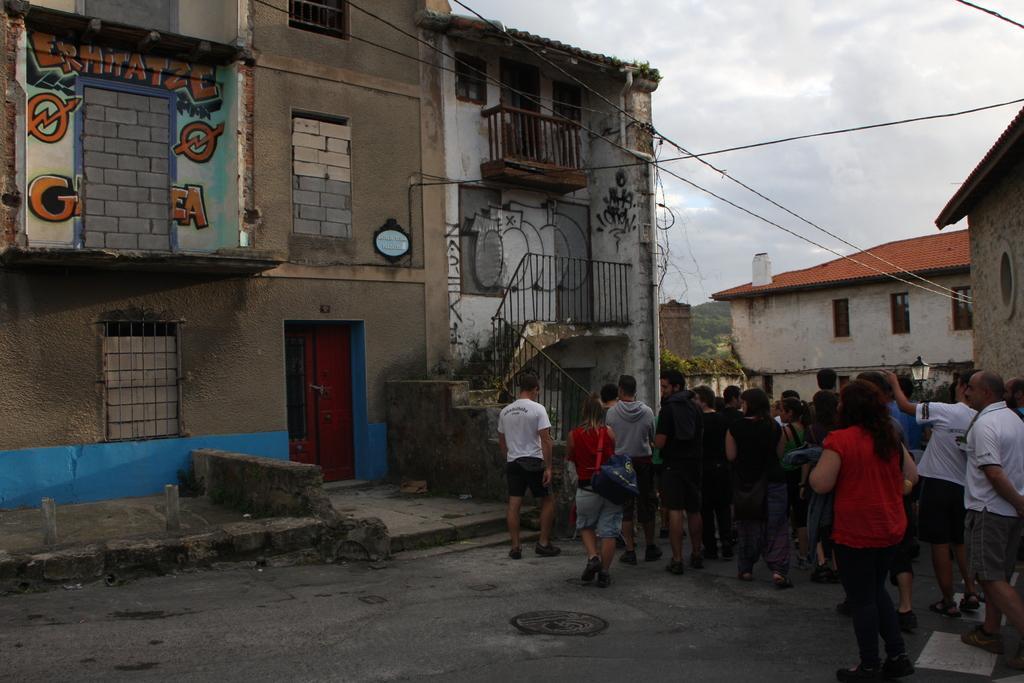How would you summarize this image in a sentence or two? In this image there are people walking on a road, in the background there are houses and the sky. 